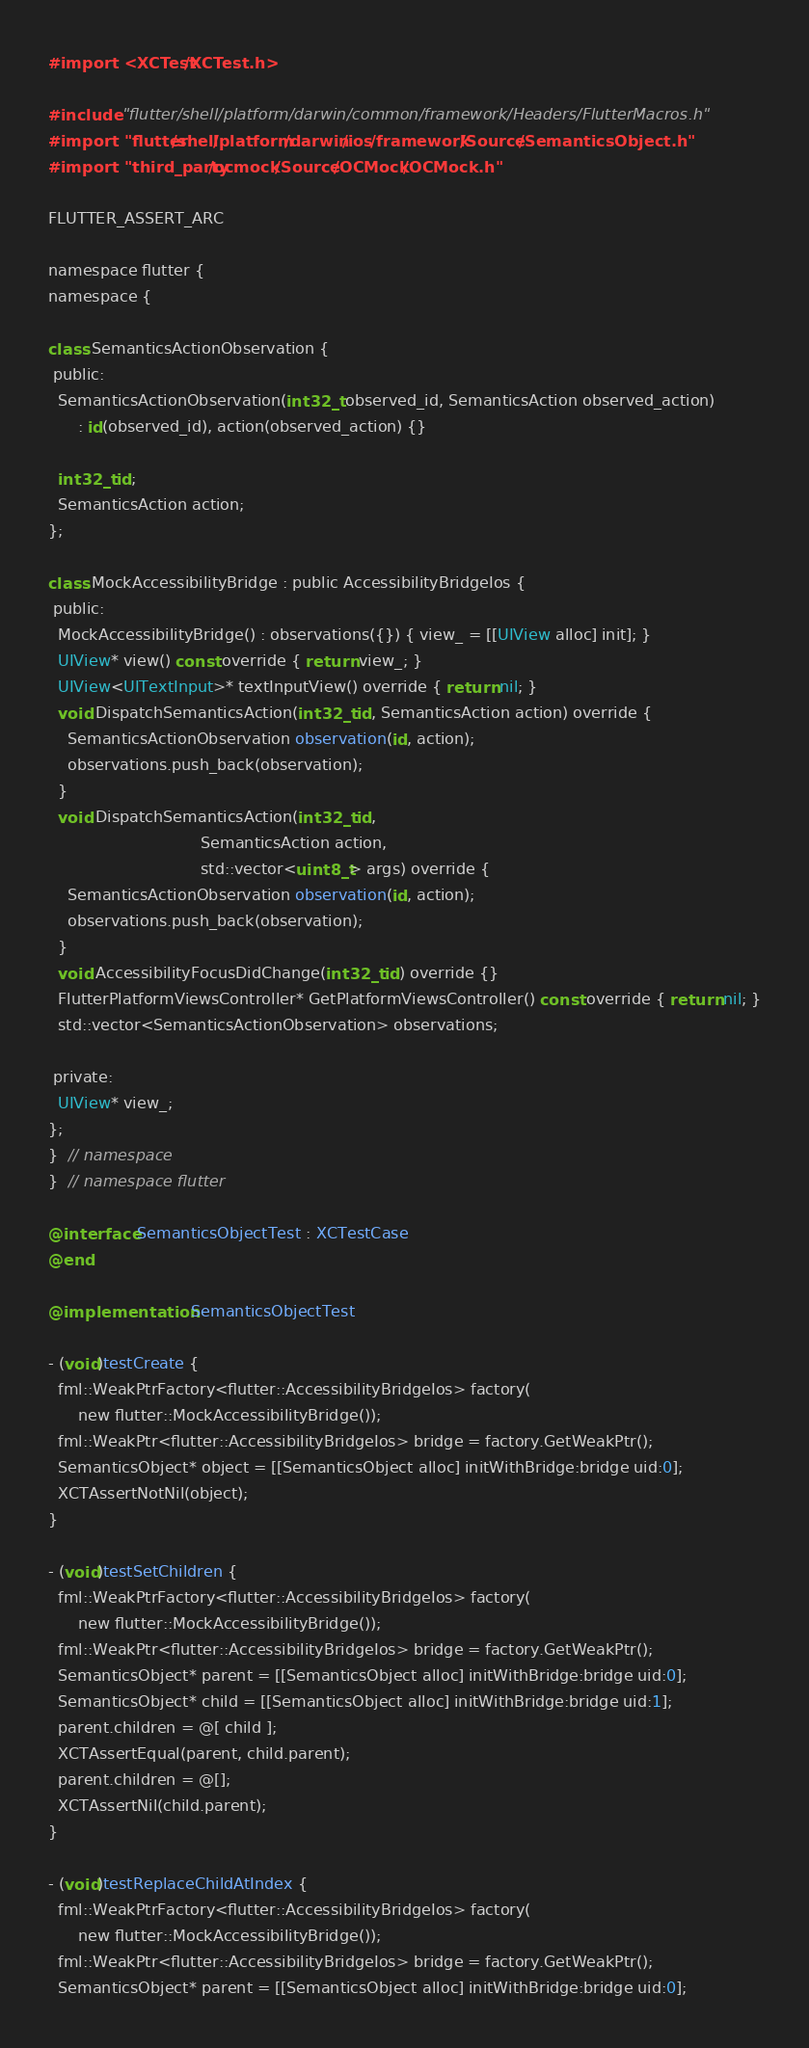<code> <loc_0><loc_0><loc_500><loc_500><_ObjectiveC_>#import <XCTest/XCTest.h>

#include "flutter/shell/platform/darwin/common/framework/Headers/FlutterMacros.h"
#import "flutter/shell/platform/darwin/ios/framework/Source/SemanticsObject.h"
#import "third_party/ocmock/Source/OCMock/OCMock.h"

FLUTTER_ASSERT_ARC

namespace flutter {
namespace {

class SemanticsActionObservation {
 public:
  SemanticsActionObservation(int32_t observed_id, SemanticsAction observed_action)
      : id(observed_id), action(observed_action) {}

  int32_t id;
  SemanticsAction action;
};

class MockAccessibilityBridge : public AccessibilityBridgeIos {
 public:
  MockAccessibilityBridge() : observations({}) { view_ = [[UIView alloc] init]; }
  UIView* view() const override { return view_; }
  UIView<UITextInput>* textInputView() override { return nil; }
  void DispatchSemanticsAction(int32_t id, SemanticsAction action) override {
    SemanticsActionObservation observation(id, action);
    observations.push_back(observation);
  }
  void DispatchSemanticsAction(int32_t id,
                               SemanticsAction action,
                               std::vector<uint8_t> args) override {
    SemanticsActionObservation observation(id, action);
    observations.push_back(observation);
  }
  void AccessibilityFocusDidChange(int32_t id) override {}
  FlutterPlatformViewsController* GetPlatformViewsController() const override { return nil; }
  std::vector<SemanticsActionObservation> observations;

 private:
  UIView* view_;
};
}  // namespace
}  // namespace flutter

@interface SemanticsObjectTest : XCTestCase
@end

@implementation SemanticsObjectTest

- (void)testCreate {
  fml::WeakPtrFactory<flutter::AccessibilityBridgeIos> factory(
      new flutter::MockAccessibilityBridge());
  fml::WeakPtr<flutter::AccessibilityBridgeIos> bridge = factory.GetWeakPtr();
  SemanticsObject* object = [[SemanticsObject alloc] initWithBridge:bridge uid:0];
  XCTAssertNotNil(object);
}

- (void)testSetChildren {
  fml::WeakPtrFactory<flutter::AccessibilityBridgeIos> factory(
      new flutter::MockAccessibilityBridge());
  fml::WeakPtr<flutter::AccessibilityBridgeIos> bridge = factory.GetWeakPtr();
  SemanticsObject* parent = [[SemanticsObject alloc] initWithBridge:bridge uid:0];
  SemanticsObject* child = [[SemanticsObject alloc] initWithBridge:bridge uid:1];
  parent.children = @[ child ];
  XCTAssertEqual(parent, child.parent);
  parent.children = @[];
  XCTAssertNil(child.parent);
}

- (void)testReplaceChildAtIndex {
  fml::WeakPtrFactory<flutter::AccessibilityBridgeIos> factory(
      new flutter::MockAccessibilityBridge());
  fml::WeakPtr<flutter::AccessibilityBridgeIos> bridge = factory.GetWeakPtr();
  SemanticsObject* parent = [[SemanticsObject alloc] initWithBridge:bridge uid:0];</code> 